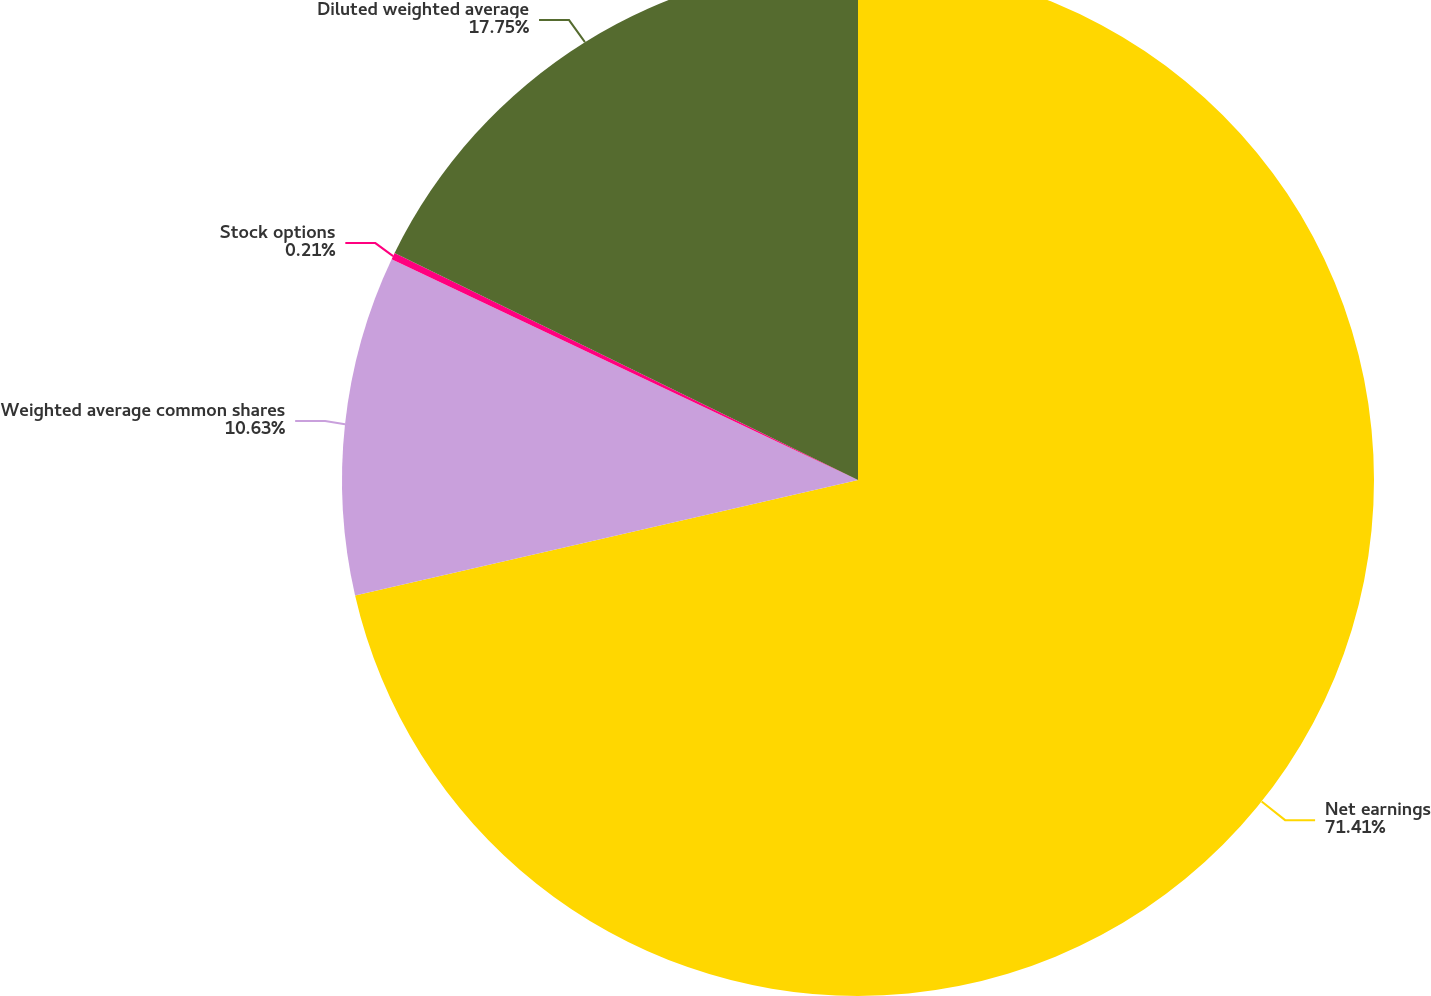Convert chart to OTSL. <chart><loc_0><loc_0><loc_500><loc_500><pie_chart><fcel>Net earnings<fcel>Weighted average common shares<fcel>Stock options<fcel>Diluted weighted average<nl><fcel>71.4%<fcel>10.63%<fcel>0.21%<fcel>17.75%<nl></chart> 